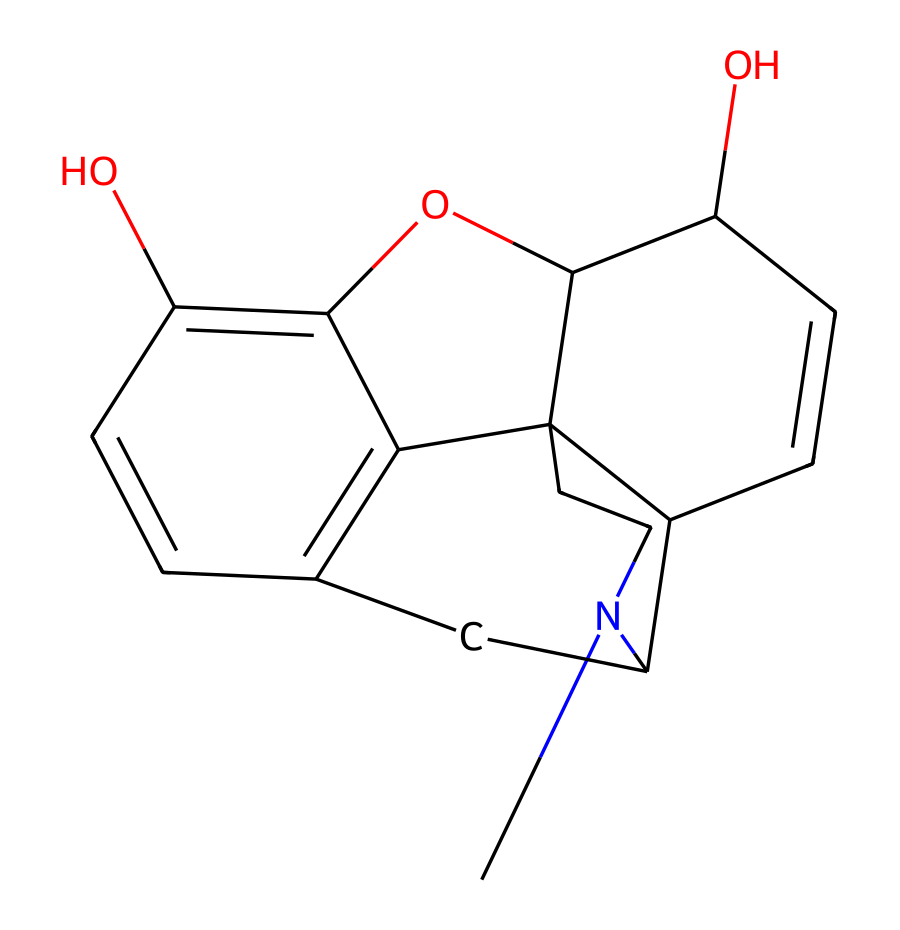What is the primary functional group present in morphine? The structure of morphine contains hydroxyl (-OH) groups. There are two hydroxyl groups indicated by the presence of oxygen atoms bonded to hydrogen.
Answer: hydroxyl groups How many rings are present in the morphine structure? Upon examining the chemical structure, morphine has five interconnected rings. This is evidenced by the cyclic nature of the structure seen in the SMILES.
Answer: five What is the molecular formula of morphine? By decoding the SMILES representation and counting the atoms, the molecular formula for morphine is C17H19NO3, which accounts for 17 carbon, 19 hydrogen, one nitrogen, and three oxygen atoms.
Answer: C17H19NO3 Which atoms in morphine contributes to its analgesic properties? The nitrogen atom present in the structure, specifically in the piperidine ring, plays a significant role in the interaction with opioid receptors, leading to analgesic effects.
Answer: nitrogen atom What type of chemical compound is morphine classified as? Morphine is classified as an opioid alkaloid due to its nitrogen-containing structure and its pharmacological properties associated with opioid receptors.
Answer: opioid alkaloid Does morphine contain any aromatic rings? Yes, morphine contains an aromatic ring in its structure, which can be identified by its alternating double bonds within a cyclic arrangement, characteristic of aromatic compounds.
Answer: yes What impact do the hydroxyl groups have on the solubility of morphine? The presence of hydroxyl groups increases the polarity of morphine, enhancing its solubility in water, which is a common trait for substances with multiple -OH groups.
Answer: increases solubility 